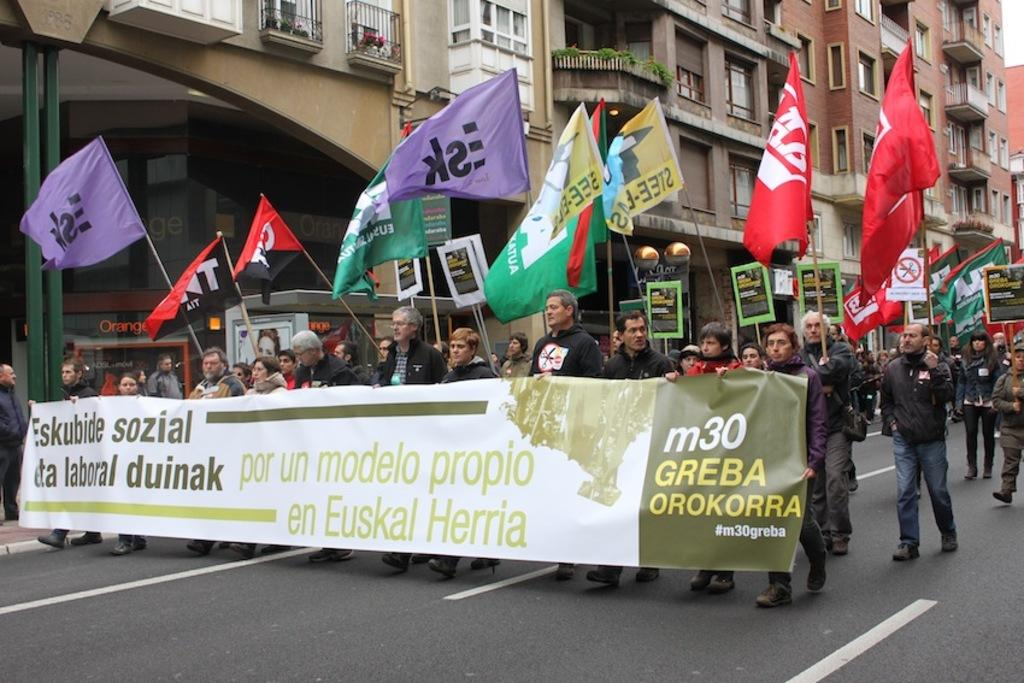Who is present in the image? There are people in the image. What are the people doing in the image? The people are protesting. What can be seen in the image besides the people? There are flags and a banner in the image. Where is the protest taking place? The protest is taking place on a road. What can be seen in the background of the image? There are houses in the background of the image. What type of dirt is being used to write the message on the banner? There is no dirt present in the image, and the message on the banner is not written with dirt. 